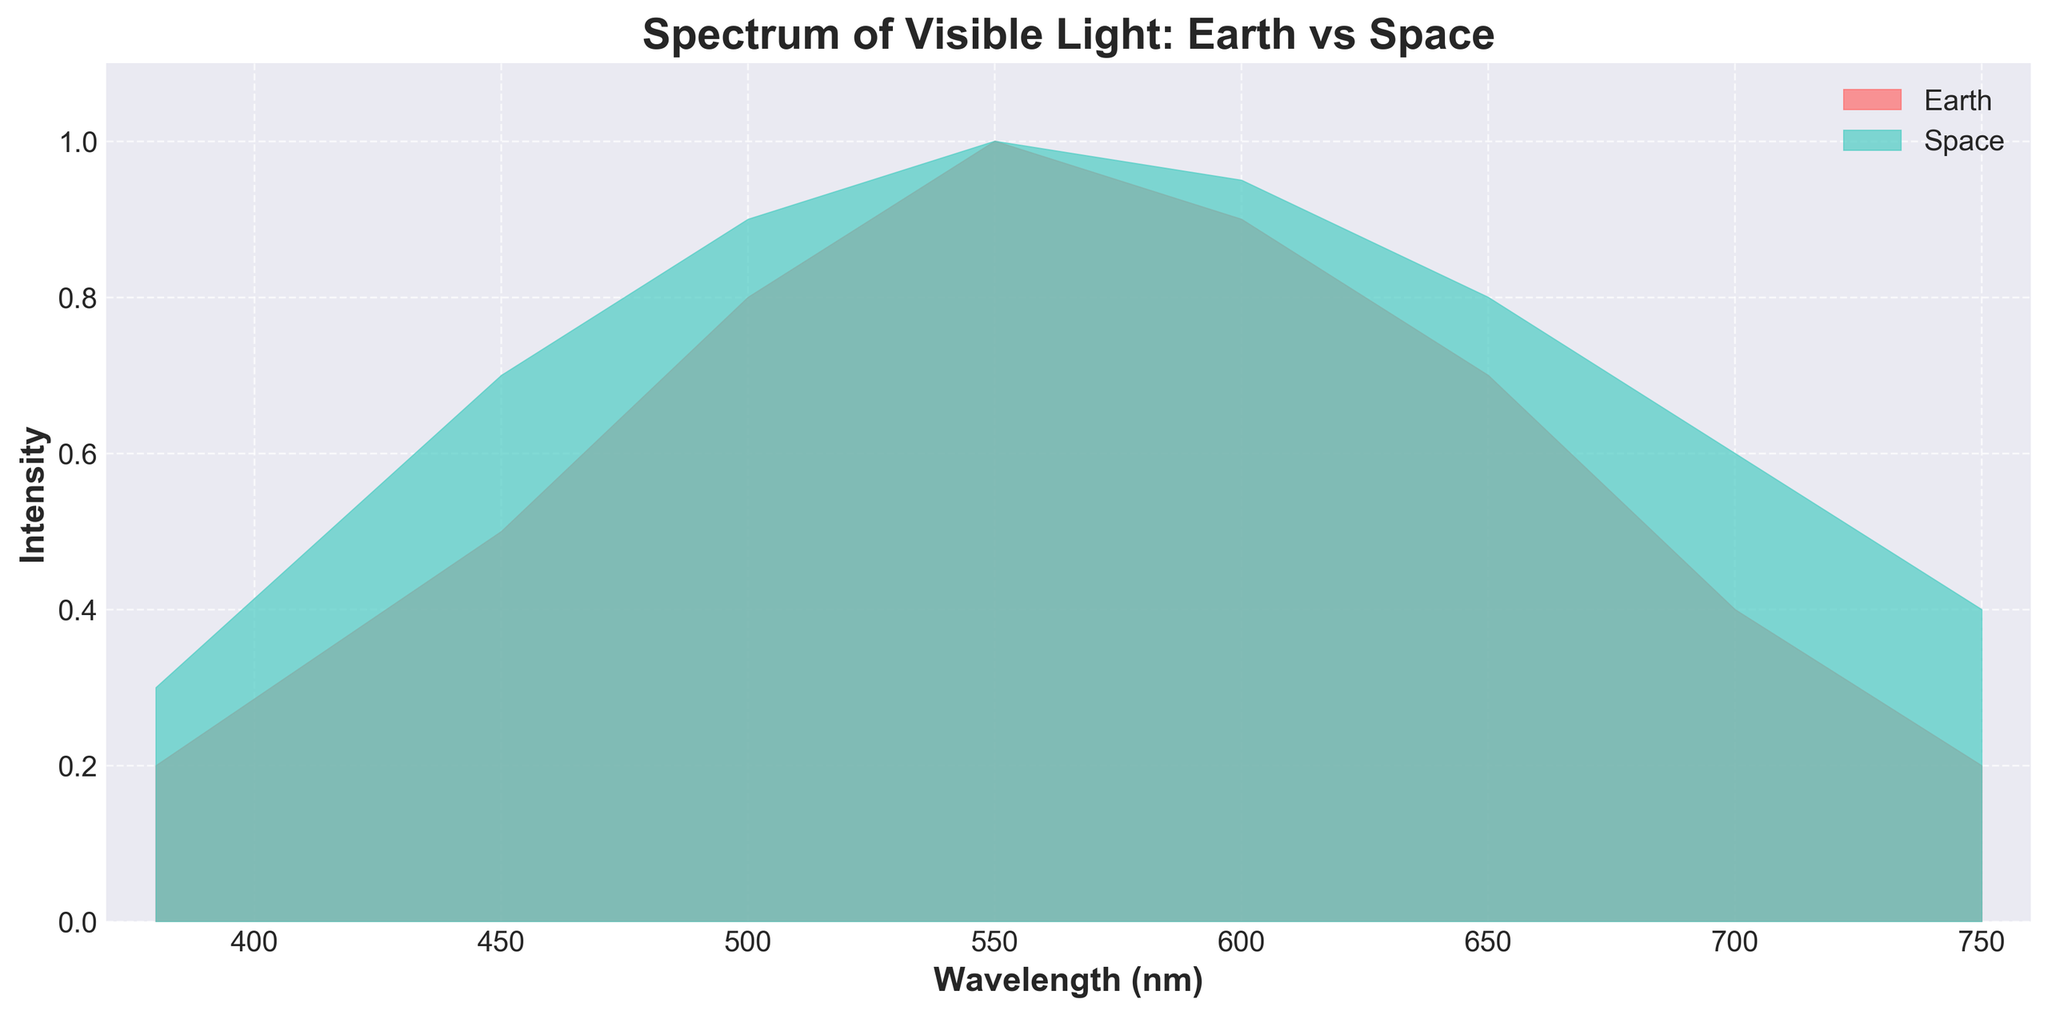What is the title of the figure? The title of the figure can be found at the top of the plot, displayed in bold font.
Answer: Spectrum of Visible Light: Earth vs Space What is the wavelength range shown in the plot? To find the wavelength range, look at the x-axis labels, which define the lower and upper limits.
Answer: 370-760 nm Which location has higher intensity at 450 nm? At 450 nm, compare the intensity values for both Earth and Space. The higher value indicates the location with higher intensity.
Answer: Space What is the highest intensity value in the plot and at what wavelength does it occur? Identify the highest point on the y-axis and the corresponding x-axis value for both locations.
Answer: 1.0 at 550 nm Compare the intensity at 700 nm for Earth and Space. Which one is higher, and what are their values? Look at the intensity values at 700 nm for both locations to determine which one is higher.
Answer: Space; Earth: 0.4, Space: 0.6 How does the intensity change from 380 nm to 550 nm for Earth? Observe the intensity values starting at 380 nm up to 550 nm on the plot to see the trend.
Answer: Increases Calculate the average intensity value for Earth between 600 and 750 nm. Take the intensity values at 600 nm, 650 nm, 700 nm, and 750 nm for Earth, sum them up and divide by 4 for the average.
Answer: (0.9 + 0.7 + 0.4 + 0.2) / 4 = 0.55 Which color represents the data observed from Space? Look at the legend on the upper right, which matches colors to their respective locations.
Answer: Teal What is the difference in intensity between Earth and Space at 600 nm? Subtract the intensity value for Earth from that of Space at 600 nm.
Answer: 0.05 How does the intensity observed from Space change from 380 nm to 750 nm? Identify the trend by observing the intensity values at 380 nm, 450 nm, 500 nm, 550 nm, 600 nm, 650 nm, 700 nm, and 750 nm from Space.
Answer: Increases then decreases 